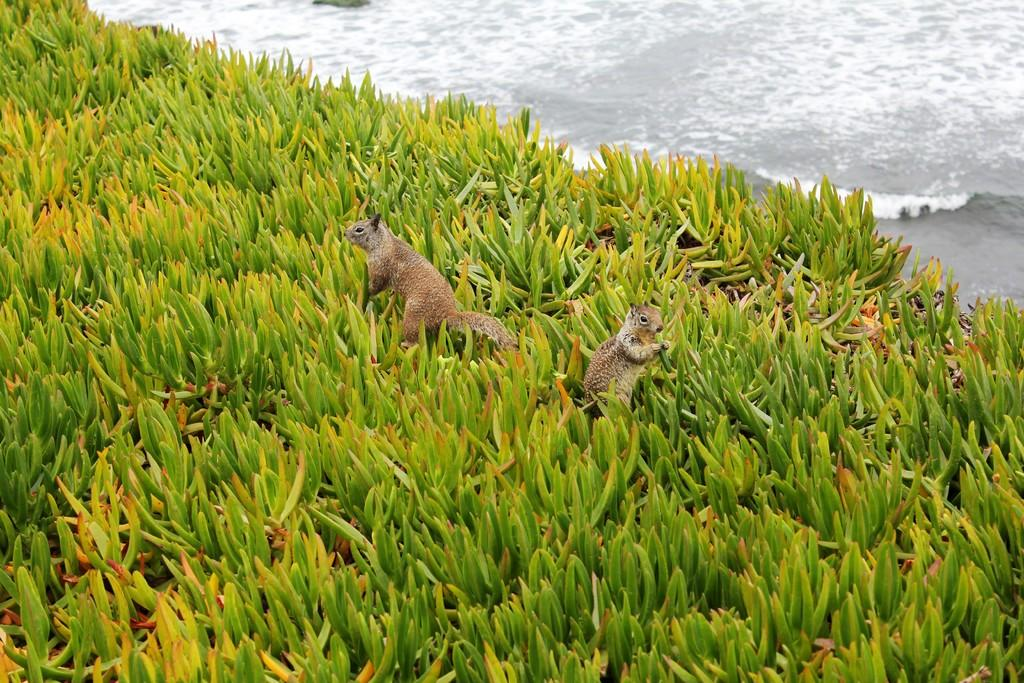What type of vegetation can be seen in the image? There are leaves in the image. How many animals are present in the image? There are two animals in the image. What can be seen at the top of the image? There is water visible at the top of the image. What type of street can be seen in the image? There is no street present in the image. Is there any eggnog visible in the image? There is no eggnog present in the image. 